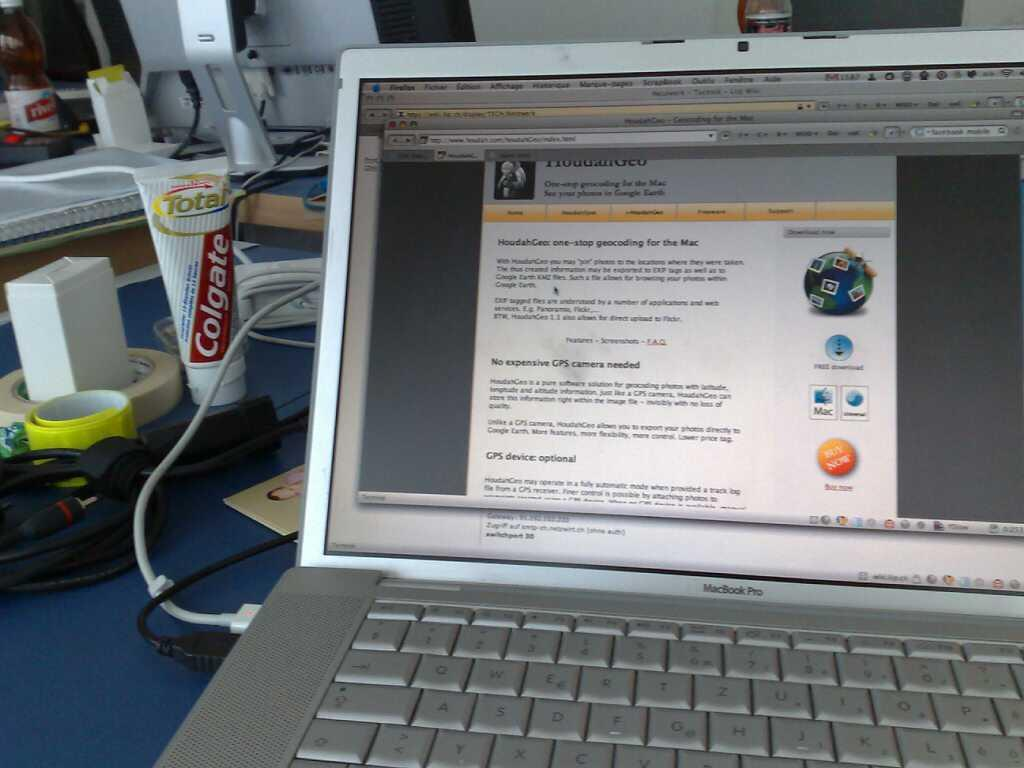<image>
Create a compact narrative representing the image presented. A tube of colgate toothpaste sits on a desk with a laptop. 